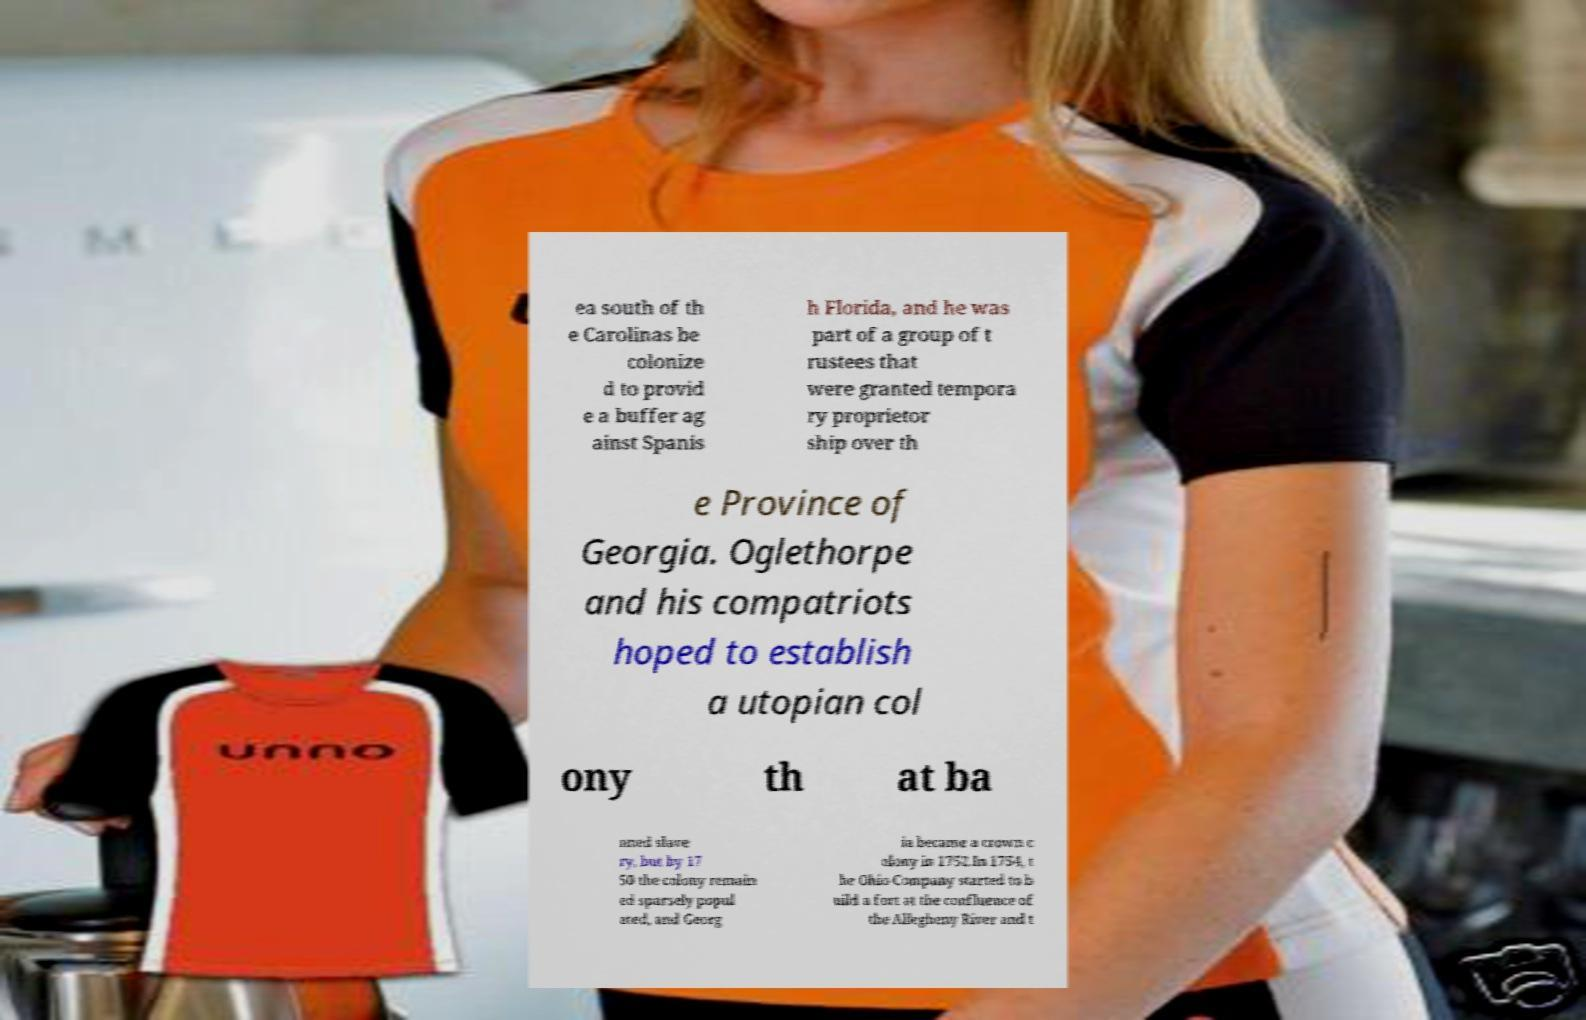Could you assist in decoding the text presented in this image and type it out clearly? ea south of th e Carolinas be colonize d to provid e a buffer ag ainst Spanis h Florida, and he was part of a group of t rustees that were granted tempora ry proprietor ship over th e Province of Georgia. Oglethorpe and his compatriots hoped to establish a utopian col ony th at ba nned slave ry, but by 17 50 the colony remain ed sparsely popul ated, and Georg ia became a crown c olony in 1752.In 1754, t he Ohio Company started to b uild a fort at the confluence of the Allegheny River and t 